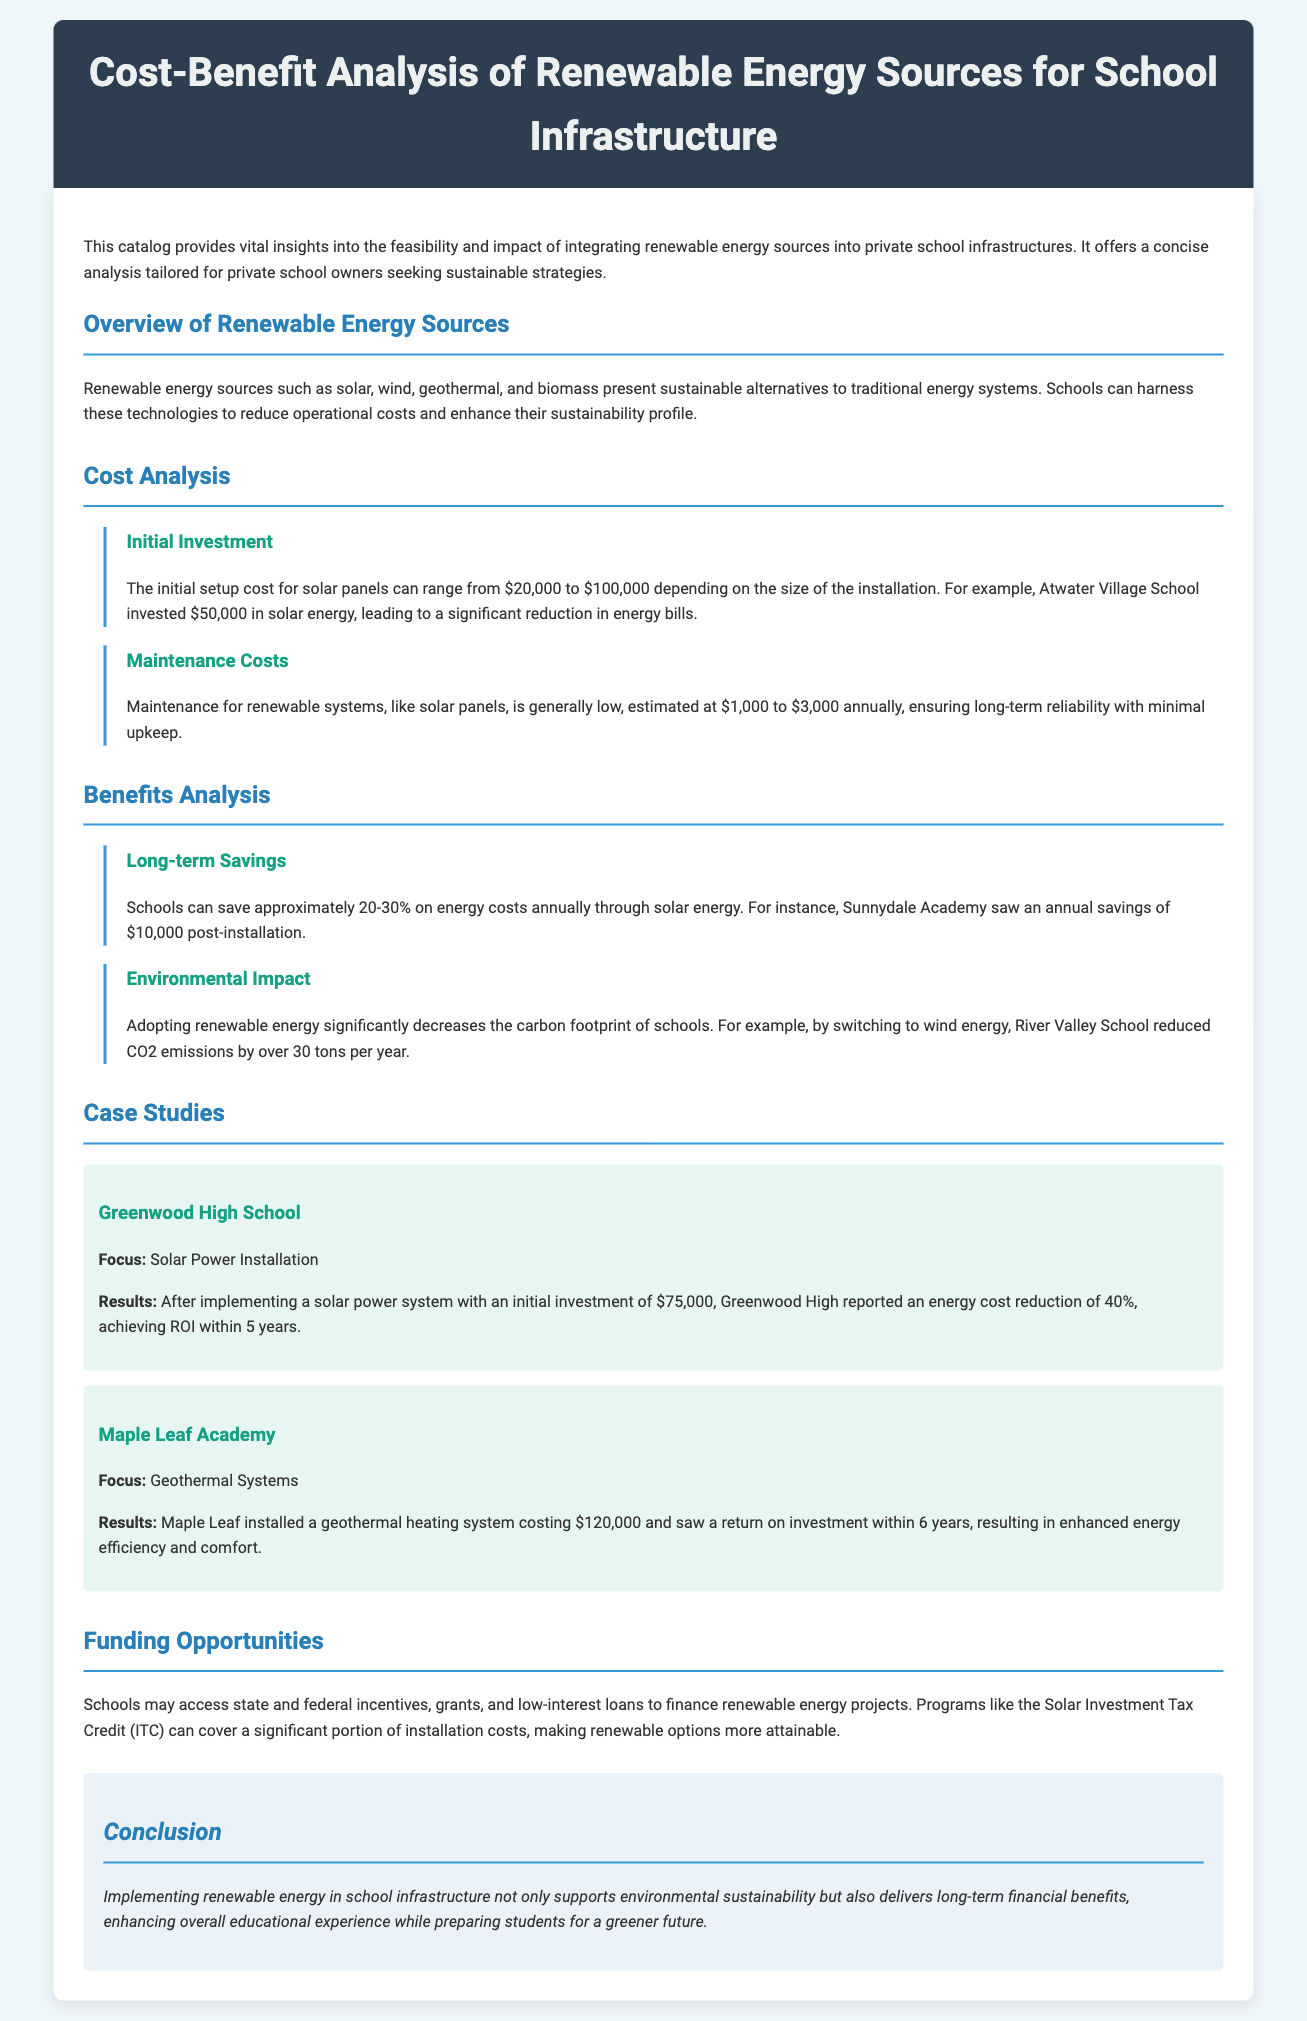what is the title of the catalog? The title of the catalog is the main heading located at the top of the document.
Answer: Cost-Benefit Analysis of Renewable Energy Sources for School Infrastructure what are the four renewable energy sources mentioned? The renewable energy sources listed in the overview section of the document are types of energy systems that schools can utilize.
Answer: solar, wind, geothermal, biomass what is the initial investment range for solar panels? This refers to the cost outlined in the cost analysis section for setting up solar panel systems.
Answer: $20,000 to $100,000 how much can schools save annually on energy costs through solar energy? This figure is stated in the benefits analysis section and reflects the potential savings from adopting solar energy.
Answer: 20-30% what was the initial investment amount for Greenwood High School's solar system? The specific investment amount for the case study of Greenwood High School is mentioned under the case studies section.
Answer: $75,000 how many tons of CO2 emissions did River Valley School reduce by switching to wind energy? This is a specific environmental outcome highlighted in the benefits analysis section related to the impact of switching energy sources.
Answer: 30 tons what funding opportunity program is mentioned for financing renewable energy projects? This is a specific program mentioned in the funding opportunities section which aids schools in financing their renewable energy projects.
Answer: Solar Investment Tax Credit (ITC) what was the return on investment period for Maple Leaf Academy's geothermal system? The duration for ROI is specified in the case study of Maple Leaf Academy, indicating the effectiveness of the geothermal investment.
Answer: 6 years what is the estimated annual maintenance cost for renewable energy systems? This number is provided in the maintenance costs subsection of the cost analysis section, reflecting ongoing expenses after installation.
Answer: $1,000 to $3,000 